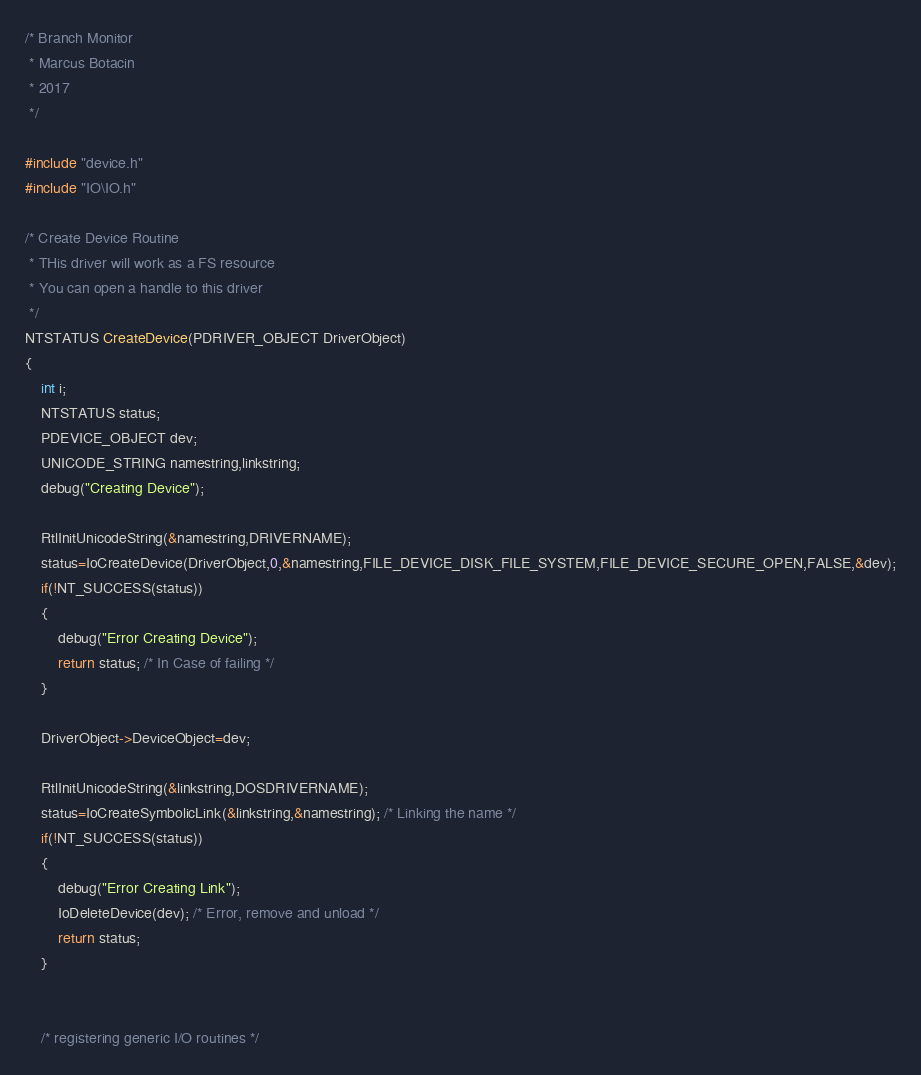<code> <loc_0><loc_0><loc_500><loc_500><_C_>/* Branch Monitor
 * Marcus Botacin
 * 2017
 */

#include "device.h"
#include "IO\IO.h"

/* Create Device Routine
 * THis driver will work as a FS resource
 * You can open a handle to this driver 
 */
NTSTATUS CreateDevice(PDRIVER_OBJECT DriverObject)
{
	int i;
	NTSTATUS status;
	PDEVICE_OBJECT dev;
	UNICODE_STRING namestring,linkstring;
	debug("Creating Device");

	RtlInitUnicodeString(&namestring,DRIVERNAME); 
	status=IoCreateDevice(DriverObject,0,&namestring,FILE_DEVICE_DISK_FILE_SYSTEM,FILE_DEVICE_SECURE_OPEN,FALSE,&dev);
	if(!NT_SUCCESS(status))
	{
		debug("Error Creating Device");
		return status; /* In Case of failing */
	}

	DriverObject->DeviceObject=dev;

	RtlInitUnicodeString(&linkstring,DOSDRIVERNAME);
	status=IoCreateSymbolicLink(&linkstring,&namestring); /* Linking the name */
	if(!NT_SUCCESS(status))
	{
		debug("Error Creating Link");
		IoDeleteDevice(dev); /* Error, remove and unload */
		return status;
	}


	/* registering generic I/O routines */</code> 